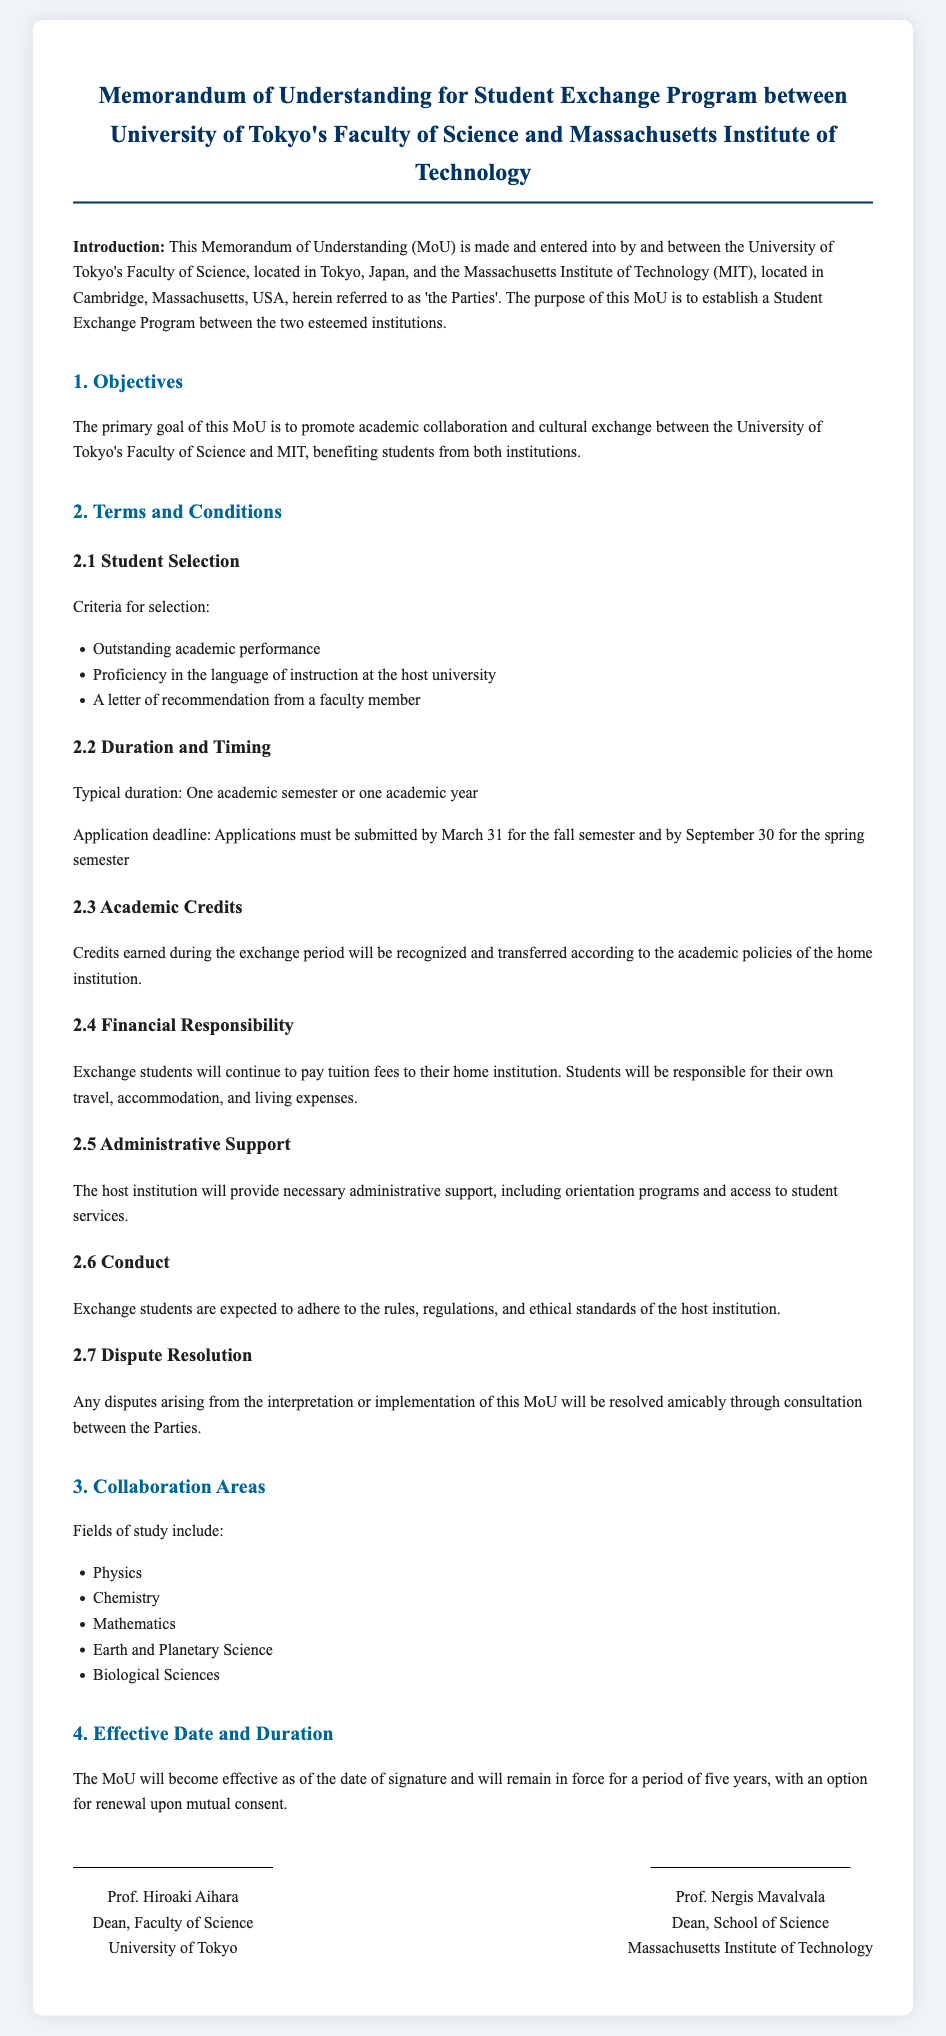What is the purpose of the MoU? The MoU aims to establish a Student Exchange Program between the University of Tokyo's Faculty of Science and MIT.
Answer: Student Exchange Program Who are the Parties involved in the MoU? The Parties are the University of Tokyo's Faculty of Science and the Massachusetts Institute of Technology.
Answer: University of Tokyo's Faculty of Science and MIT What is the typical duration of the exchange? The typical duration of the exchange is one academic semester or one academic year.
Answer: One academic semester or one academic year When is the application deadline for the fall semester? Applications must be submitted by March 31 for the fall semester.
Answer: March 31 What areas of study are included in the collaboration? The collaboration includes fields such as Physics, Chemistry, Mathematics, Earth and Planetary Science, and Biological Sciences.
Answer: Physics, Chemistry, Mathematics, Earth and Planetary Science, Biological Sciences What is expected from exchange students in terms of conduct? Exchange students are expected to adhere to the rules, regulations, and ethical standards of the host institution.
Answer: Adhere to rules, regulations, and ethical standards How long is the MoU effective? The MoU will remain in force for a period of five years.
Answer: Five years What type of financial responsibility do exchange students have? Exchange students are responsible for their own travel, accommodation, and living expenses.
Answer: Travel, accommodation, and living expenses 